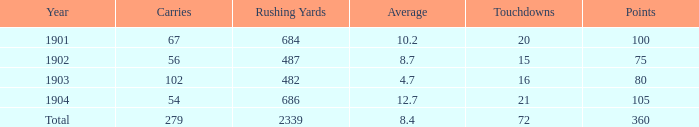What is the average number of carries that have more than 72 touchdowns? None. 